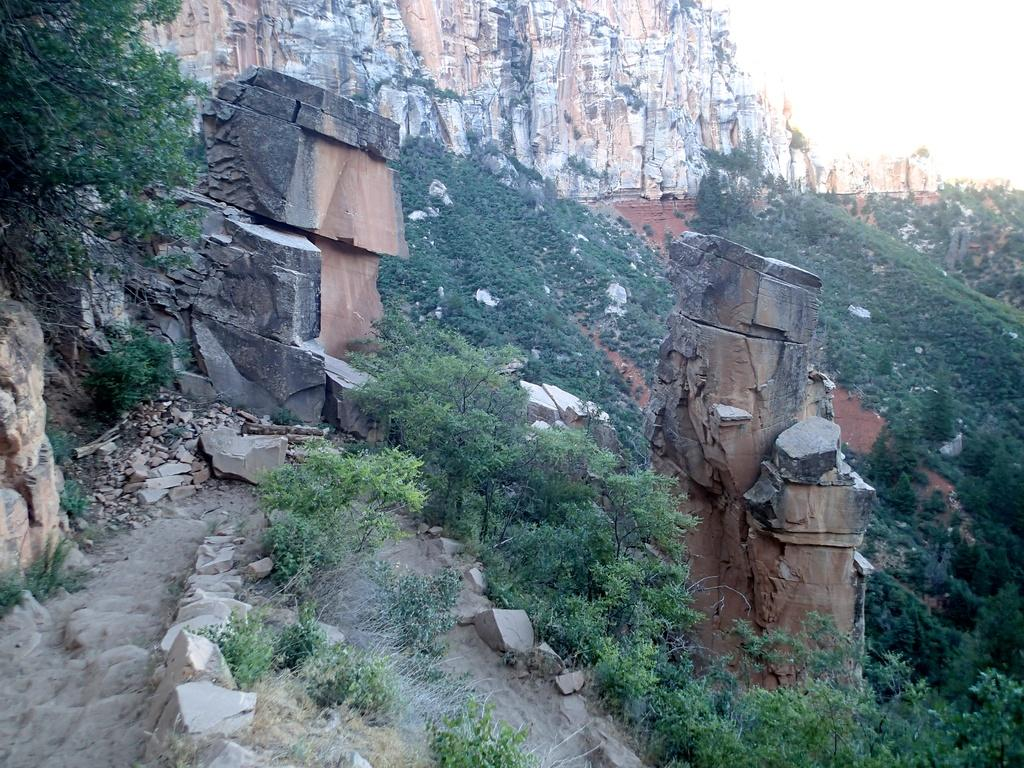What type of vegetation is present in the image? There are many trees in the image. What can be seen on the ground in the image? There are stones on the ground in the image. What type of geological formation is visible in the background of the image? There are rock hills in the background of the image. How many dogs are present in the image? There are no dogs present in the image. What type of produce can be seen growing on the trees in the image? There is no produce visible on the trees in the image; they are not fruit-bearing trees. 